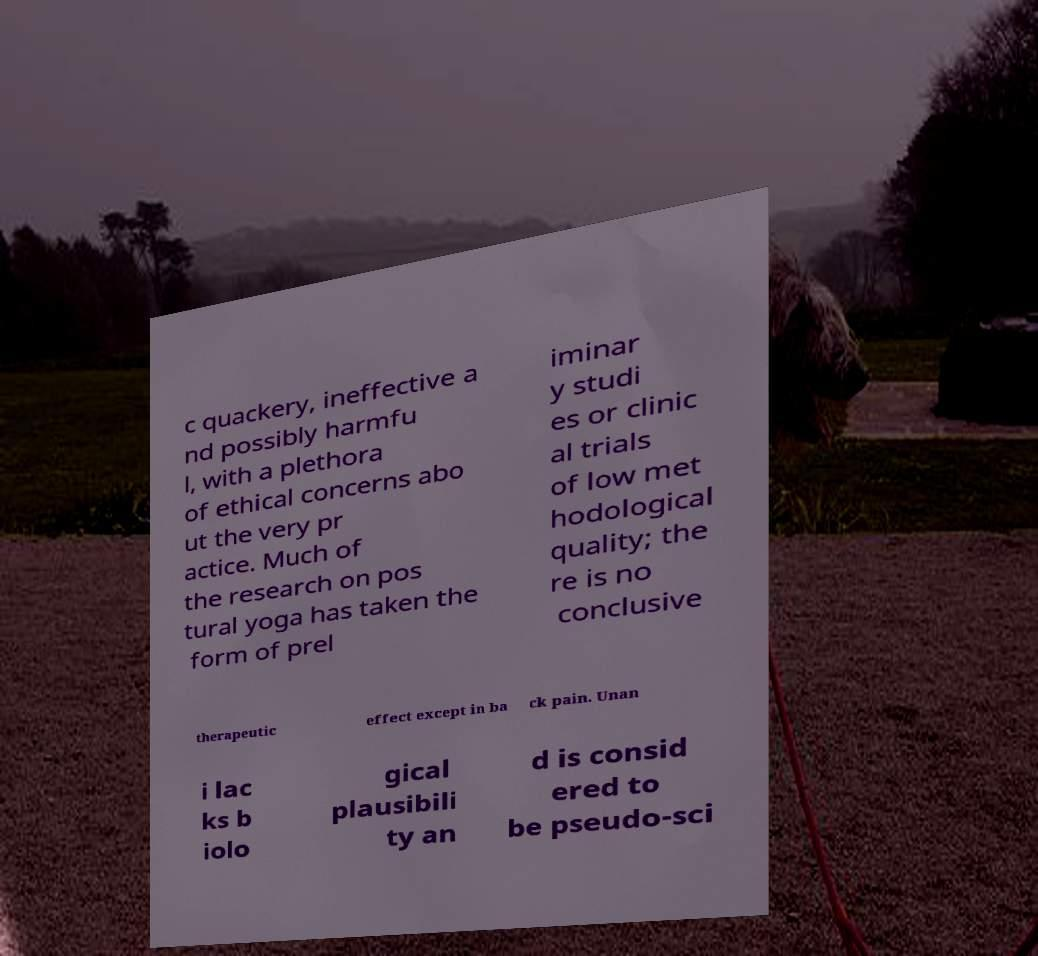Can you accurately transcribe the text from the provided image for me? c quackery, ineffective a nd possibly harmfu l, with a plethora of ethical concerns abo ut the very pr actice. Much of the research on pos tural yoga has taken the form of prel iminar y studi es or clinic al trials of low met hodological quality; the re is no conclusive therapeutic effect except in ba ck pain. Unan i lac ks b iolo gical plausibili ty an d is consid ered to be pseudo-sci 